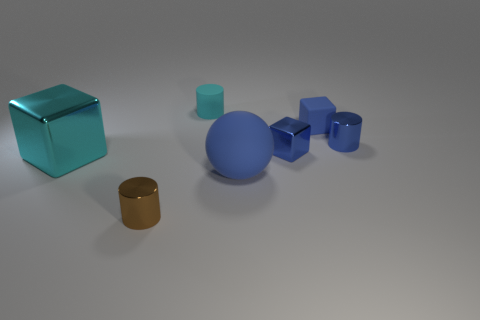What material is the small cylinder in front of the metallic block to the right of the large blue rubber ball?
Ensure brevity in your answer.  Metal. What is the shape of the blue matte thing that is behind the large cyan thing that is on the left side of the blue matte object to the left of the matte block?
Your answer should be very brief. Cube. There is a large cyan thing that is the same shape as the small blue rubber object; what is its material?
Keep it short and to the point. Metal. How many small brown objects are there?
Provide a short and direct response. 1. The tiny rubber object to the right of the tiny cyan object has what shape?
Provide a short and direct response. Cube. The metallic cube to the left of the tiny cylinder in front of the blue matte ball that is to the left of the blue matte cube is what color?
Ensure brevity in your answer.  Cyan. The small blue thing that is made of the same material as the big blue object is what shape?
Give a very brief answer. Cube. Is the number of small blue blocks less than the number of brown metallic things?
Give a very brief answer. No. Do the tiny cyan cylinder and the cyan block have the same material?
Keep it short and to the point. No. What number of other things are the same color as the rubber cylinder?
Your answer should be very brief. 1. 